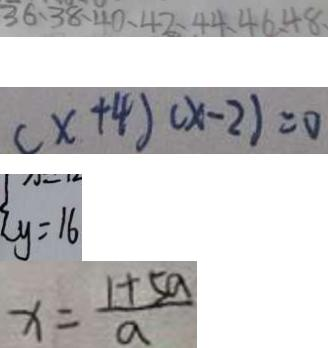Convert formula to latex. <formula><loc_0><loc_0><loc_500><loc_500>3 6 、 3 8 、 4 0 、 4 2 、 4 4 、 4 6 、 4 8 
 ( x + 4 ) ( x - 2 ) = 0 
 y = 1 6 
 x = \frac { 1 + 5 a } { a }</formula> 